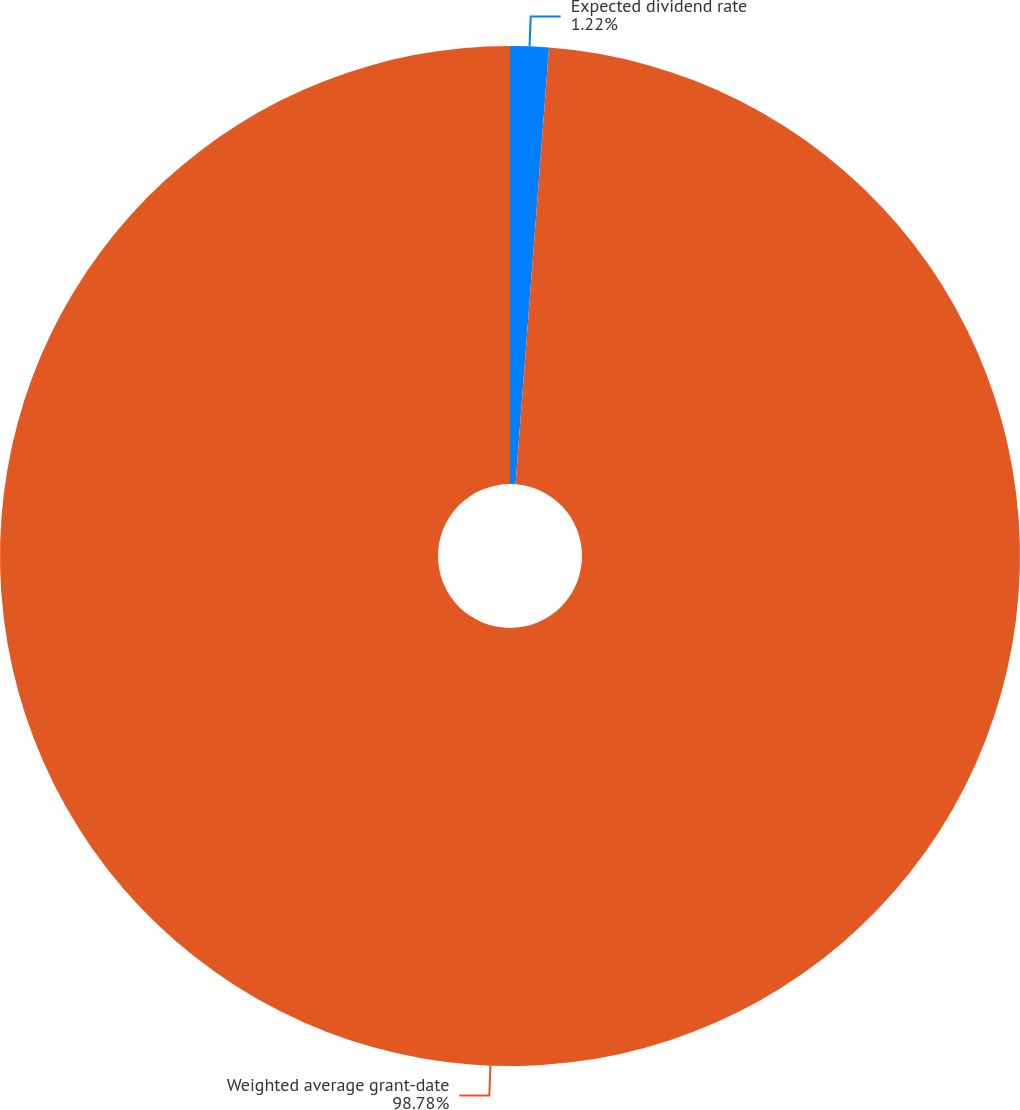Convert chart. <chart><loc_0><loc_0><loc_500><loc_500><pie_chart><fcel>Expected dividend rate<fcel>Weighted average grant-date<nl><fcel>1.22%<fcel>98.78%<nl></chart> 